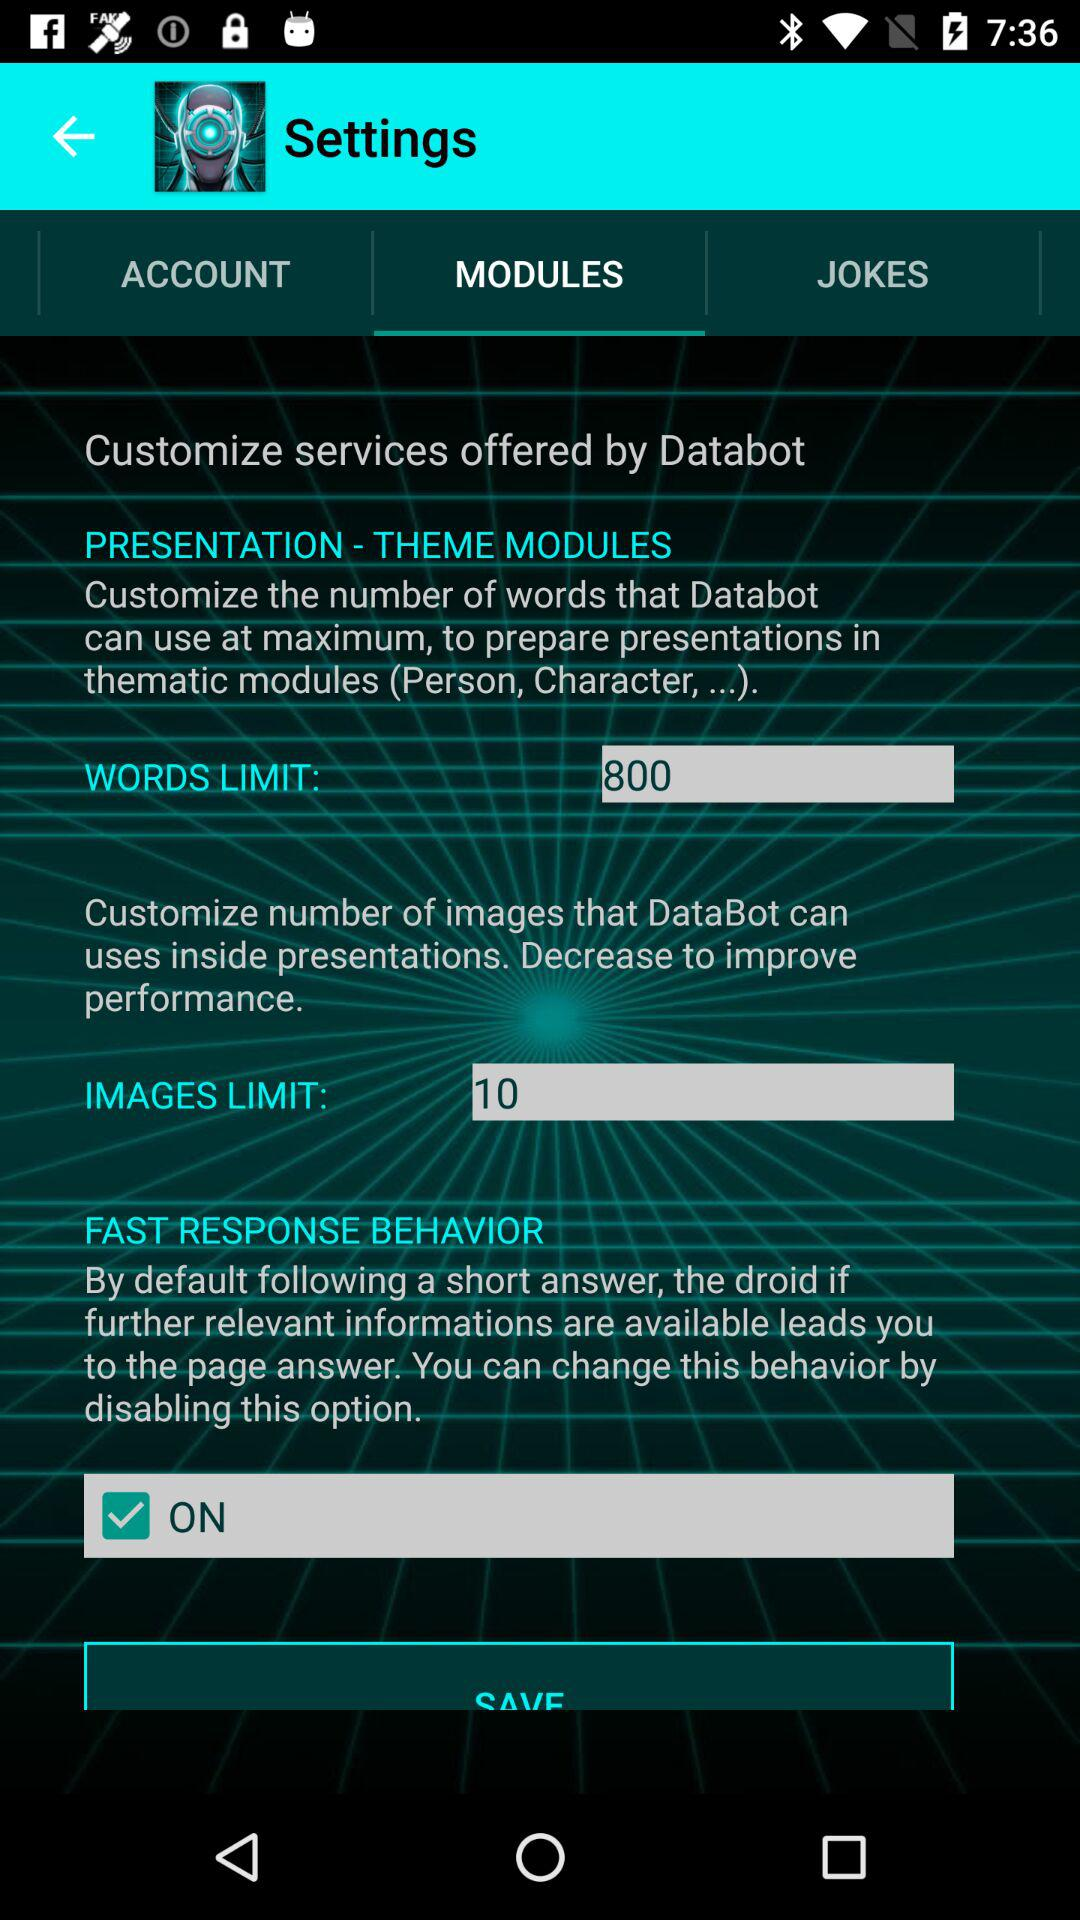What is the limit for images? The limit for images is 10. 